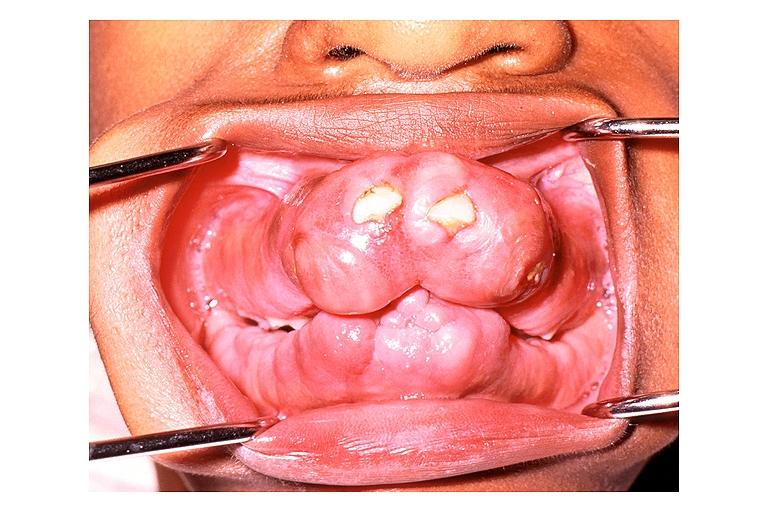does carcinoma show gingival fibromatosis?
Answer the question using a single word or phrase. No 